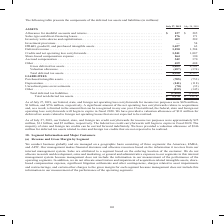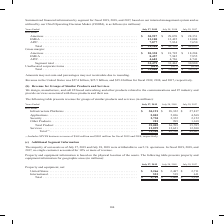According to Cisco Systems's financial document, What was the revenue in the United States for fiscal 2018? According to the financial document, $25.5 billion. The relevant text states: "Revenue in the United States was $27.4 billion, $25.5 billion, and $25.0 billion for fiscal 2019, 2018, and 2017, respectively...." Also, What are the regions that the company operates in? The document contains multiple relevant values: Americas, EMEA, APJC. From the document: "isting of three segments: the Americas, EMEA, and APJC. Our management makes financial decisions and allocates resources based on the information it r..." Also, What was the gross margin from Americas in 2019? According to the financial document, 20,338 (in millions). The relevant text states: ",904 $ 49,330 $ 48,005 Gross margin: Americas . $ 20,338 $ 18,792 $ 18,284 EMEA . 8,457 7,945 7,855 APJC. . 4,683 4,726 4,741 Segment total . 33,479 31,463..." Also, can you calculate: What was the change in the gross margin from APJC between 2017 and 2018? Based on the calculation: 4,726-4,741, the result is -15 (in millions). This is based on the information: ",284 EMEA . 8,457 7,945 7,855 APJC. . 4,683 4,726 4,741 Segment total . 33,479 31,463 30,880 Unallocated corporate items . (813) (857) (656) Total . $ 32,6 2 $ 18,284 EMEA . 8,457 7,945 7,855 APJC. . ..." The key data points involved are: 4,726, 4,741. Also, How many years did total revenue from all segments exceed $50,000 million? Based on the analysis, there are 1 instances. The counting process: 2019. Also, can you calculate: What was the percentage change in the total gross margin from all segments between 2018 and 2019? To answer this question, I need to perform calculations using the financial data. The calculation is: (32,666-30,606)/30,606, which equals 6.73 (percentage). This is based on the information: "rate items . (813) (857) (656) Total . $ 32,666 $ 30,606 $ 30,224 ted corporate items . (813) (857) (656) Total . $ 32,666 $ 30,606 $ 30,224..." The key data points involved are: 30,606, 32,666. 